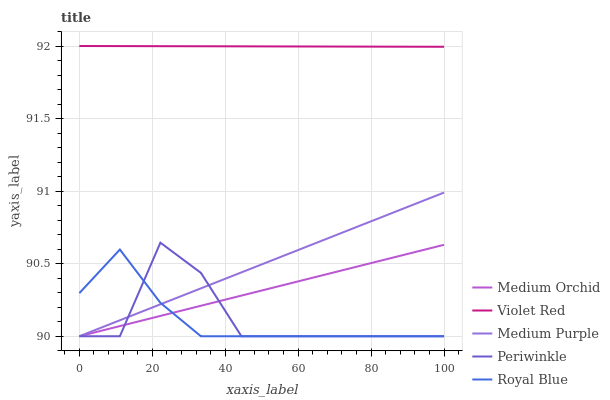Does Violet Red have the minimum area under the curve?
Answer yes or no. No. Does Royal Blue have the maximum area under the curve?
Answer yes or no. No. Is Royal Blue the smoothest?
Answer yes or no. No. Is Royal Blue the roughest?
Answer yes or no. No. Does Violet Red have the lowest value?
Answer yes or no. No. Does Royal Blue have the highest value?
Answer yes or no. No. Is Royal Blue less than Violet Red?
Answer yes or no. Yes. Is Violet Red greater than Periwinkle?
Answer yes or no. Yes. Does Royal Blue intersect Violet Red?
Answer yes or no. No. 